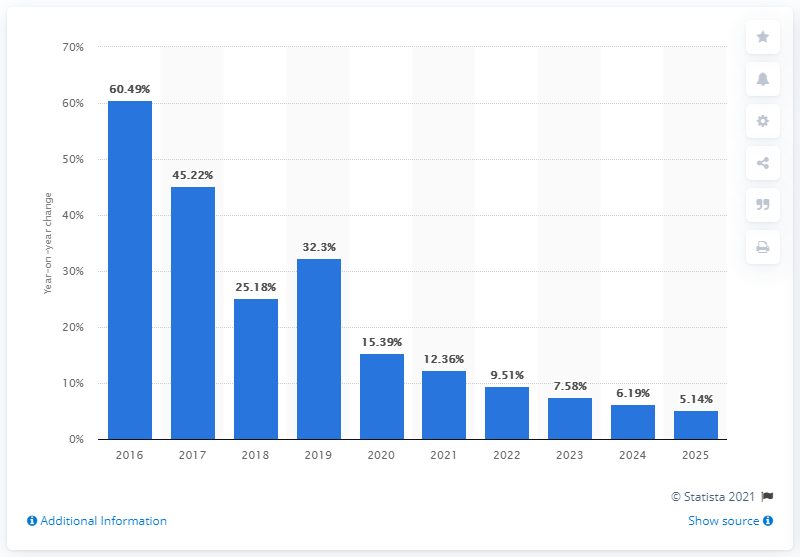Point out several critical features in this image. The growth rate for new users in India is expected to be 5.14% in 2025. 